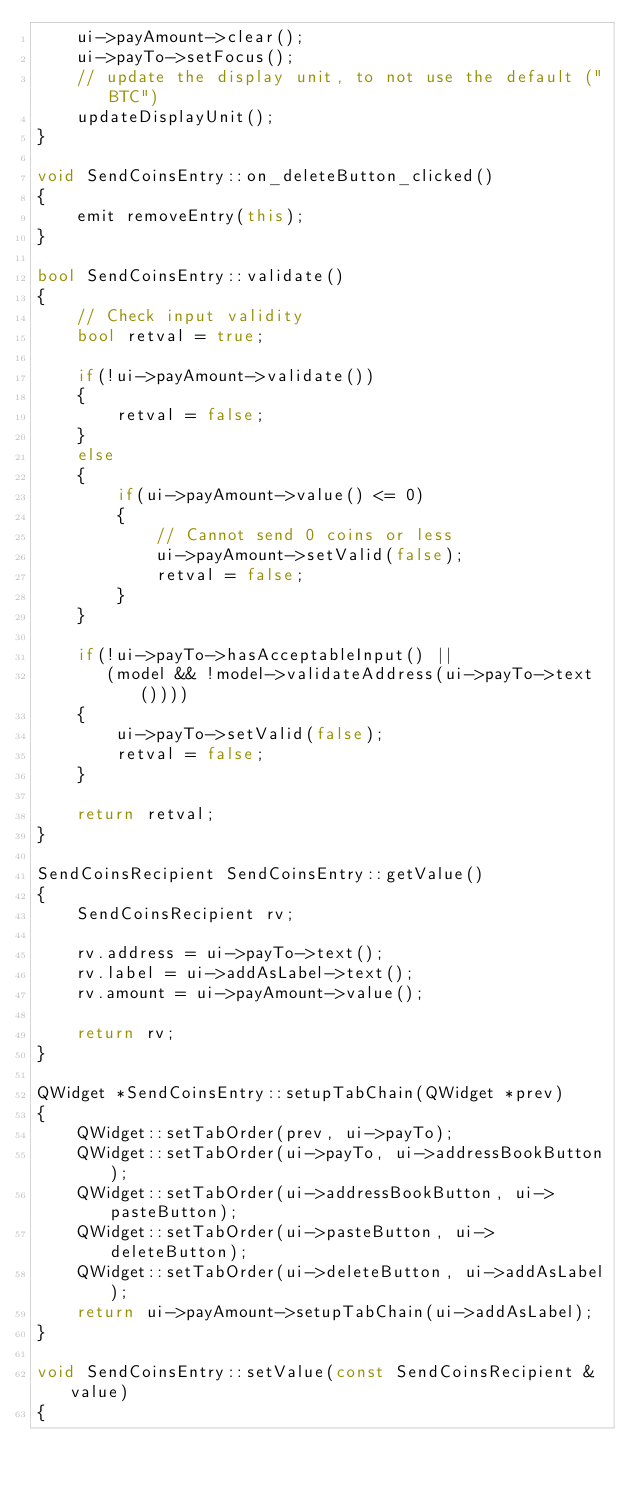<code> <loc_0><loc_0><loc_500><loc_500><_C++_>    ui->payAmount->clear();
    ui->payTo->setFocus();
    // update the display unit, to not use the default ("BTC")
    updateDisplayUnit();
}

void SendCoinsEntry::on_deleteButton_clicked()
{
    emit removeEntry(this);
}

bool SendCoinsEntry::validate()
{
    // Check input validity
    bool retval = true;

    if(!ui->payAmount->validate())
    {
        retval = false;
    }
    else
    {
        if(ui->payAmount->value() <= 0)
        {
            // Cannot send 0 coins or less
            ui->payAmount->setValid(false);
            retval = false;
        }
    }

    if(!ui->payTo->hasAcceptableInput() ||
       (model && !model->validateAddress(ui->payTo->text())))
    {
        ui->payTo->setValid(false);
        retval = false;
    }

    return retval;
}

SendCoinsRecipient SendCoinsEntry::getValue()
{
    SendCoinsRecipient rv;

    rv.address = ui->payTo->text();
    rv.label = ui->addAsLabel->text();
    rv.amount = ui->payAmount->value();

    return rv;
}

QWidget *SendCoinsEntry::setupTabChain(QWidget *prev)
{
    QWidget::setTabOrder(prev, ui->payTo);
    QWidget::setTabOrder(ui->payTo, ui->addressBookButton);
    QWidget::setTabOrder(ui->addressBookButton, ui->pasteButton);
    QWidget::setTabOrder(ui->pasteButton, ui->deleteButton);
    QWidget::setTabOrder(ui->deleteButton, ui->addAsLabel);
    return ui->payAmount->setupTabChain(ui->addAsLabel);
}

void SendCoinsEntry::setValue(const SendCoinsRecipient &value)
{</code> 